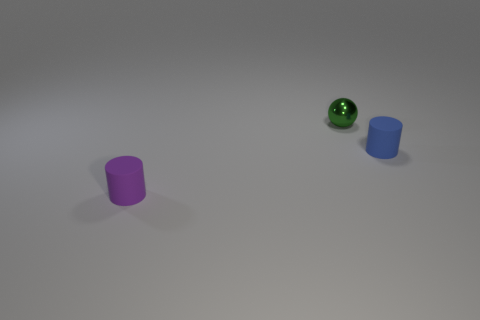There is a rubber object that is behind the small purple rubber cylinder; is it the same size as the matte cylinder left of the shiny sphere?
Give a very brief answer. Yes. Is the number of purple rubber objects that are on the right side of the green metallic thing greater than the number of small green objects that are to the right of the tiny purple matte thing?
Offer a very short reply. No. Are there any other small green balls that have the same material as the green sphere?
Your answer should be compact. No. The object that is to the right of the purple cylinder and in front of the metal ball is made of what material?
Your response must be concise. Rubber. The small metal thing is what color?
Give a very brief answer. Green. How many blue matte things have the same shape as the purple thing?
Make the answer very short. 1. Is the tiny cylinder that is to the right of the tiny ball made of the same material as the thing in front of the tiny blue rubber thing?
Your response must be concise. Yes. There is a matte object to the right of the small matte object that is on the left side of the ball; how big is it?
Keep it short and to the point. Small. Is there anything else that is the same size as the metal ball?
Your response must be concise. Yes. There is another small object that is the same shape as the tiny purple object; what material is it?
Your response must be concise. Rubber. 